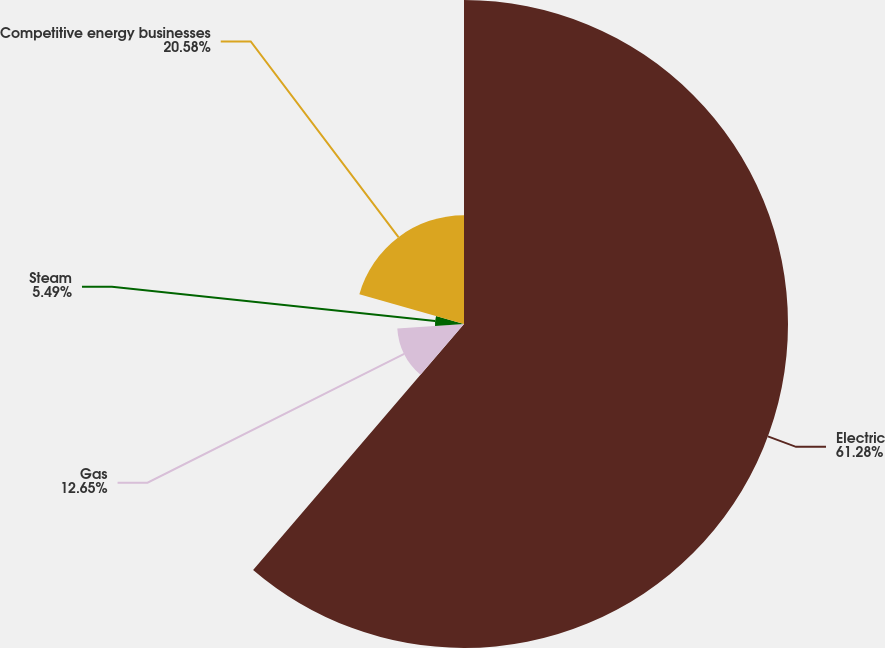<chart> <loc_0><loc_0><loc_500><loc_500><pie_chart><fcel>Electric<fcel>Gas<fcel>Steam<fcel>Competitive energy businesses<nl><fcel>61.28%<fcel>12.65%<fcel>5.49%<fcel>20.58%<nl></chart> 